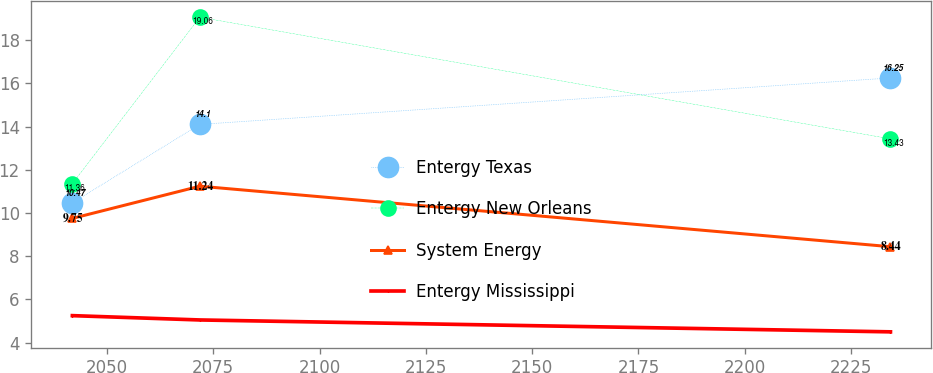Convert chart to OTSL. <chart><loc_0><loc_0><loc_500><loc_500><line_chart><ecel><fcel>Entergy Texas<fcel>Entergy New Orleans<fcel>System Energy<fcel>Entergy Mississippi<nl><fcel>2041.88<fcel>10.47<fcel>11.36<fcel>9.75<fcel>5.25<nl><fcel>2071.85<fcel>14.1<fcel>19.06<fcel>11.24<fcel>5.05<nl><fcel>2234.26<fcel>16.25<fcel>13.43<fcel>8.44<fcel>4.5<nl></chart> 